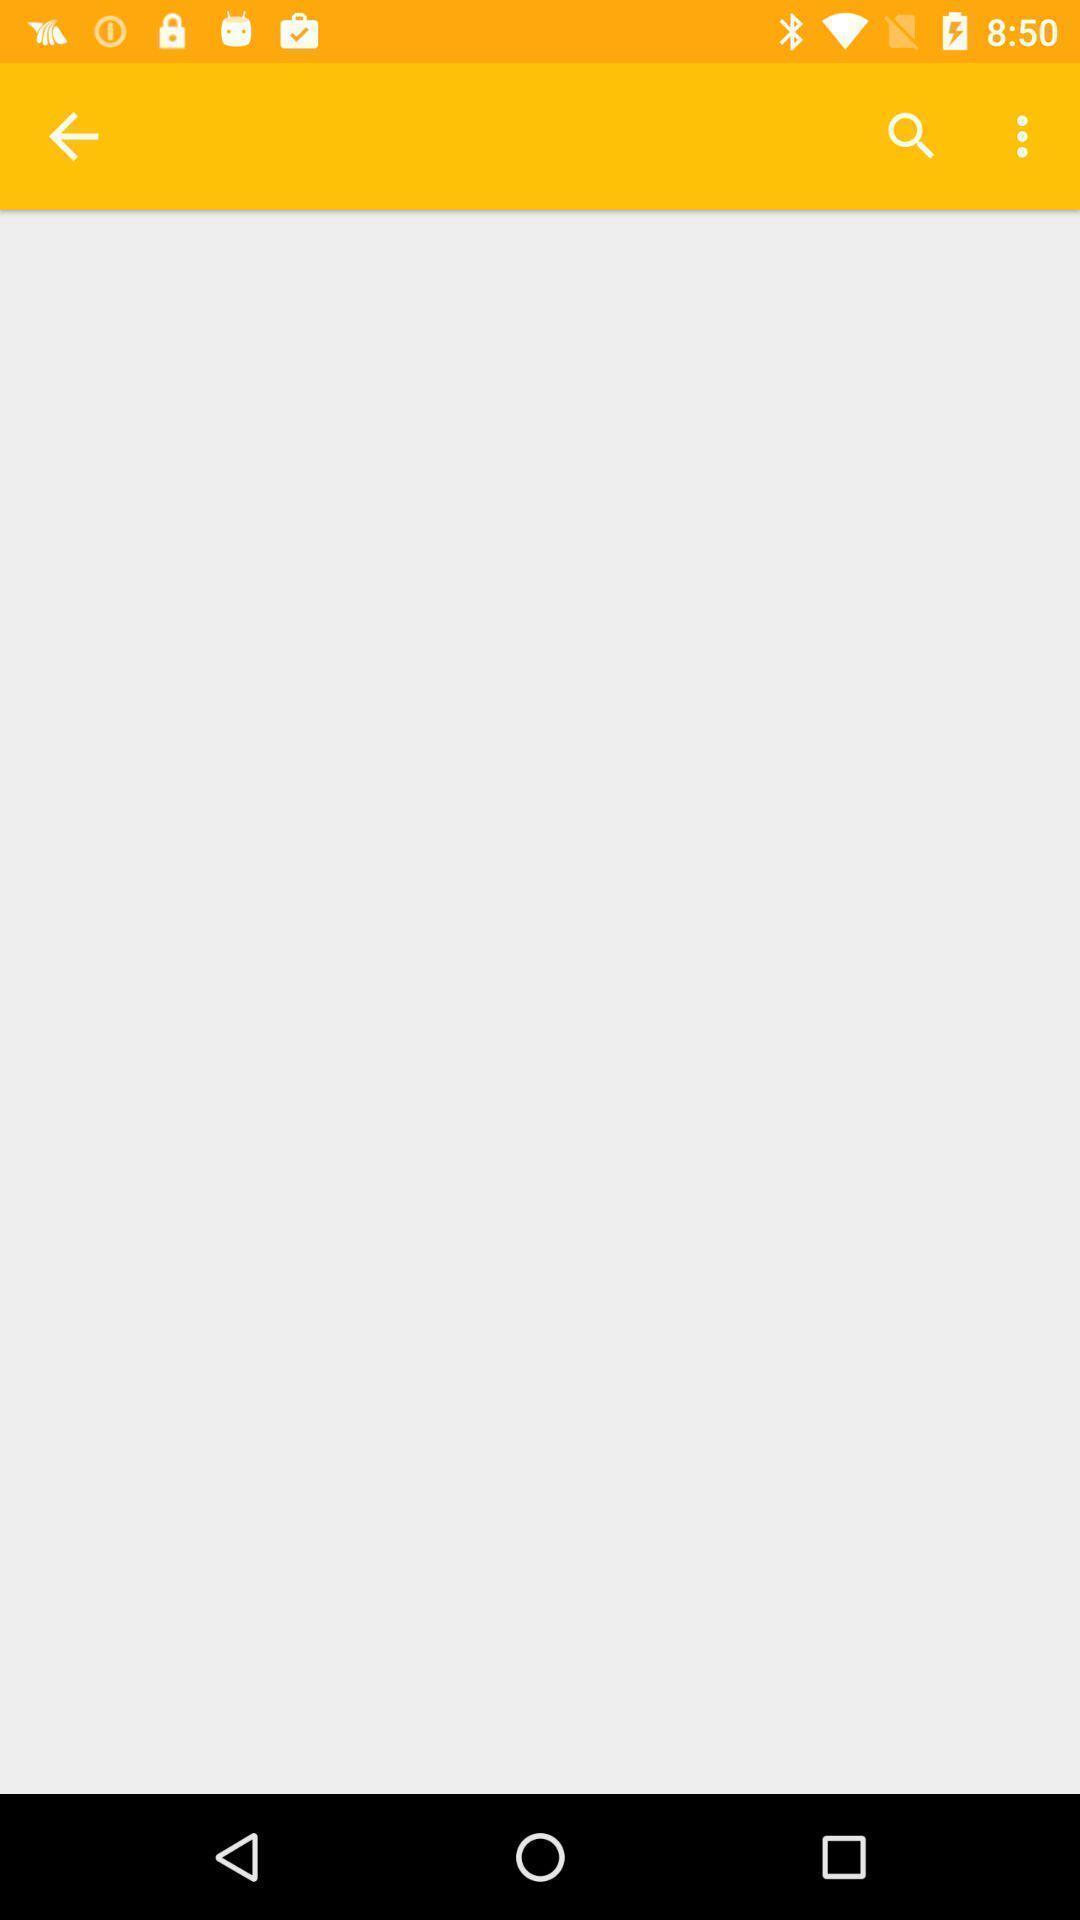Provide a textual representation of this image. Page showing a blank screen. 